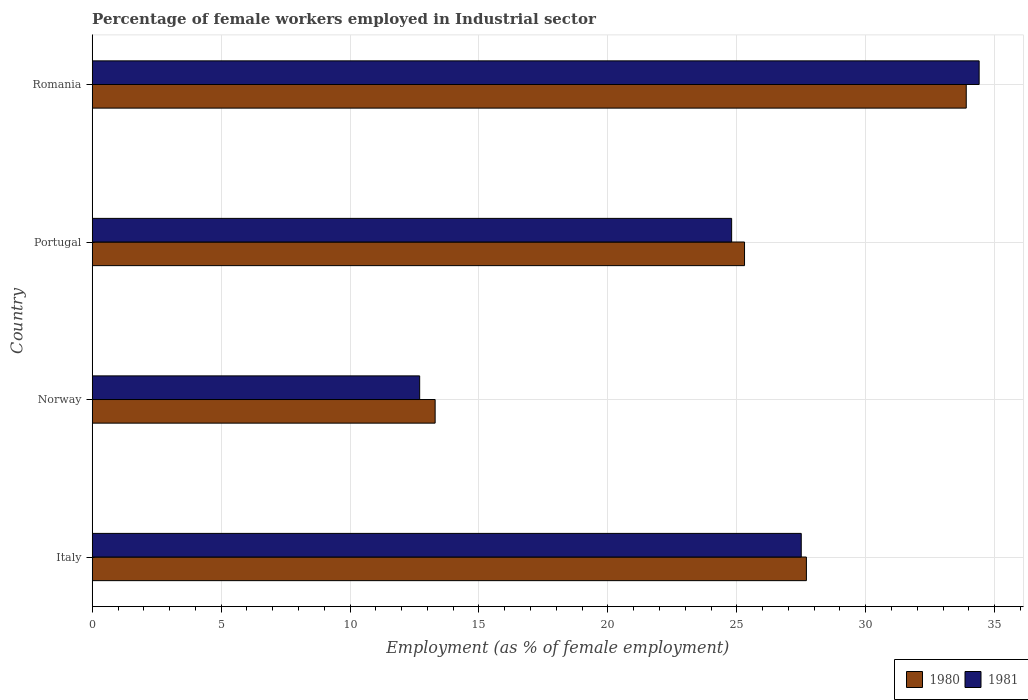Are the number of bars on each tick of the Y-axis equal?
Your answer should be very brief. Yes. How many bars are there on the 3rd tick from the top?
Your answer should be very brief. 2. What is the percentage of females employed in Industrial sector in 1980 in Portugal?
Provide a short and direct response. 25.3. Across all countries, what is the maximum percentage of females employed in Industrial sector in 1980?
Provide a short and direct response. 33.9. Across all countries, what is the minimum percentage of females employed in Industrial sector in 1980?
Offer a very short reply. 13.3. In which country was the percentage of females employed in Industrial sector in 1980 maximum?
Provide a short and direct response. Romania. What is the total percentage of females employed in Industrial sector in 1980 in the graph?
Make the answer very short. 100.2. What is the difference between the percentage of females employed in Industrial sector in 1981 in Italy and that in Romania?
Your answer should be very brief. -6.9. What is the difference between the percentage of females employed in Industrial sector in 1980 in Portugal and the percentage of females employed in Industrial sector in 1981 in Italy?
Give a very brief answer. -2.2. What is the average percentage of females employed in Industrial sector in 1980 per country?
Keep it short and to the point. 25.05. What is the difference between the percentage of females employed in Industrial sector in 1980 and percentage of females employed in Industrial sector in 1981 in Portugal?
Provide a succinct answer. 0.5. What is the ratio of the percentage of females employed in Industrial sector in 1981 in Italy to that in Norway?
Offer a very short reply. 2.17. Is the difference between the percentage of females employed in Industrial sector in 1980 in Norway and Romania greater than the difference between the percentage of females employed in Industrial sector in 1981 in Norway and Romania?
Your answer should be compact. Yes. What is the difference between the highest and the second highest percentage of females employed in Industrial sector in 1981?
Your answer should be very brief. 6.9. What is the difference between the highest and the lowest percentage of females employed in Industrial sector in 1981?
Ensure brevity in your answer.  21.7. In how many countries, is the percentage of females employed in Industrial sector in 1981 greater than the average percentage of females employed in Industrial sector in 1981 taken over all countries?
Ensure brevity in your answer.  2. Is the sum of the percentage of females employed in Industrial sector in 1981 in Norway and Romania greater than the maximum percentage of females employed in Industrial sector in 1980 across all countries?
Make the answer very short. Yes. What does the 2nd bar from the top in Italy represents?
Your response must be concise. 1980. What does the 2nd bar from the bottom in Romania represents?
Make the answer very short. 1981. How many bars are there?
Give a very brief answer. 8. How many countries are there in the graph?
Make the answer very short. 4. Does the graph contain any zero values?
Your answer should be very brief. No. Does the graph contain grids?
Your response must be concise. Yes. Where does the legend appear in the graph?
Make the answer very short. Bottom right. How are the legend labels stacked?
Ensure brevity in your answer.  Horizontal. What is the title of the graph?
Give a very brief answer. Percentage of female workers employed in Industrial sector. Does "2003" appear as one of the legend labels in the graph?
Provide a short and direct response. No. What is the label or title of the X-axis?
Offer a very short reply. Employment (as % of female employment). What is the label or title of the Y-axis?
Your response must be concise. Country. What is the Employment (as % of female employment) of 1980 in Italy?
Offer a terse response. 27.7. What is the Employment (as % of female employment) in 1980 in Norway?
Provide a short and direct response. 13.3. What is the Employment (as % of female employment) of 1981 in Norway?
Your answer should be compact. 12.7. What is the Employment (as % of female employment) of 1980 in Portugal?
Ensure brevity in your answer.  25.3. What is the Employment (as % of female employment) of 1981 in Portugal?
Your answer should be very brief. 24.8. What is the Employment (as % of female employment) of 1980 in Romania?
Ensure brevity in your answer.  33.9. What is the Employment (as % of female employment) in 1981 in Romania?
Make the answer very short. 34.4. Across all countries, what is the maximum Employment (as % of female employment) in 1980?
Your answer should be very brief. 33.9. Across all countries, what is the maximum Employment (as % of female employment) of 1981?
Make the answer very short. 34.4. Across all countries, what is the minimum Employment (as % of female employment) of 1980?
Give a very brief answer. 13.3. Across all countries, what is the minimum Employment (as % of female employment) of 1981?
Offer a terse response. 12.7. What is the total Employment (as % of female employment) of 1980 in the graph?
Ensure brevity in your answer.  100.2. What is the total Employment (as % of female employment) in 1981 in the graph?
Your answer should be compact. 99.4. What is the difference between the Employment (as % of female employment) in 1981 in Italy and that in Norway?
Provide a succinct answer. 14.8. What is the difference between the Employment (as % of female employment) of 1980 in Italy and that in Portugal?
Give a very brief answer. 2.4. What is the difference between the Employment (as % of female employment) of 1981 in Italy and that in Romania?
Your response must be concise. -6.9. What is the difference between the Employment (as % of female employment) of 1980 in Norway and that in Portugal?
Give a very brief answer. -12. What is the difference between the Employment (as % of female employment) of 1980 in Norway and that in Romania?
Offer a very short reply. -20.6. What is the difference between the Employment (as % of female employment) in 1981 in Norway and that in Romania?
Give a very brief answer. -21.7. What is the difference between the Employment (as % of female employment) in 1981 in Portugal and that in Romania?
Make the answer very short. -9.6. What is the difference between the Employment (as % of female employment) in 1980 in Italy and the Employment (as % of female employment) in 1981 in Romania?
Keep it short and to the point. -6.7. What is the difference between the Employment (as % of female employment) in 1980 in Norway and the Employment (as % of female employment) in 1981 in Romania?
Your response must be concise. -21.1. What is the difference between the Employment (as % of female employment) of 1980 in Portugal and the Employment (as % of female employment) of 1981 in Romania?
Your response must be concise. -9.1. What is the average Employment (as % of female employment) of 1980 per country?
Your answer should be compact. 25.05. What is the average Employment (as % of female employment) in 1981 per country?
Your answer should be very brief. 24.85. What is the difference between the Employment (as % of female employment) in 1980 and Employment (as % of female employment) in 1981 in Italy?
Offer a terse response. 0.2. What is the ratio of the Employment (as % of female employment) in 1980 in Italy to that in Norway?
Provide a short and direct response. 2.08. What is the ratio of the Employment (as % of female employment) in 1981 in Italy to that in Norway?
Keep it short and to the point. 2.17. What is the ratio of the Employment (as % of female employment) of 1980 in Italy to that in Portugal?
Ensure brevity in your answer.  1.09. What is the ratio of the Employment (as % of female employment) of 1981 in Italy to that in Portugal?
Offer a terse response. 1.11. What is the ratio of the Employment (as % of female employment) of 1980 in Italy to that in Romania?
Give a very brief answer. 0.82. What is the ratio of the Employment (as % of female employment) in 1981 in Italy to that in Romania?
Make the answer very short. 0.8. What is the ratio of the Employment (as % of female employment) in 1980 in Norway to that in Portugal?
Your answer should be very brief. 0.53. What is the ratio of the Employment (as % of female employment) in 1981 in Norway to that in Portugal?
Offer a terse response. 0.51. What is the ratio of the Employment (as % of female employment) of 1980 in Norway to that in Romania?
Your answer should be compact. 0.39. What is the ratio of the Employment (as % of female employment) in 1981 in Norway to that in Romania?
Give a very brief answer. 0.37. What is the ratio of the Employment (as % of female employment) of 1980 in Portugal to that in Romania?
Provide a short and direct response. 0.75. What is the ratio of the Employment (as % of female employment) of 1981 in Portugal to that in Romania?
Make the answer very short. 0.72. What is the difference between the highest and the second highest Employment (as % of female employment) in 1981?
Ensure brevity in your answer.  6.9. What is the difference between the highest and the lowest Employment (as % of female employment) in 1980?
Offer a very short reply. 20.6. What is the difference between the highest and the lowest Employment (as % of female employment) of 1981?
Provide a short and direct response. 21.7. 